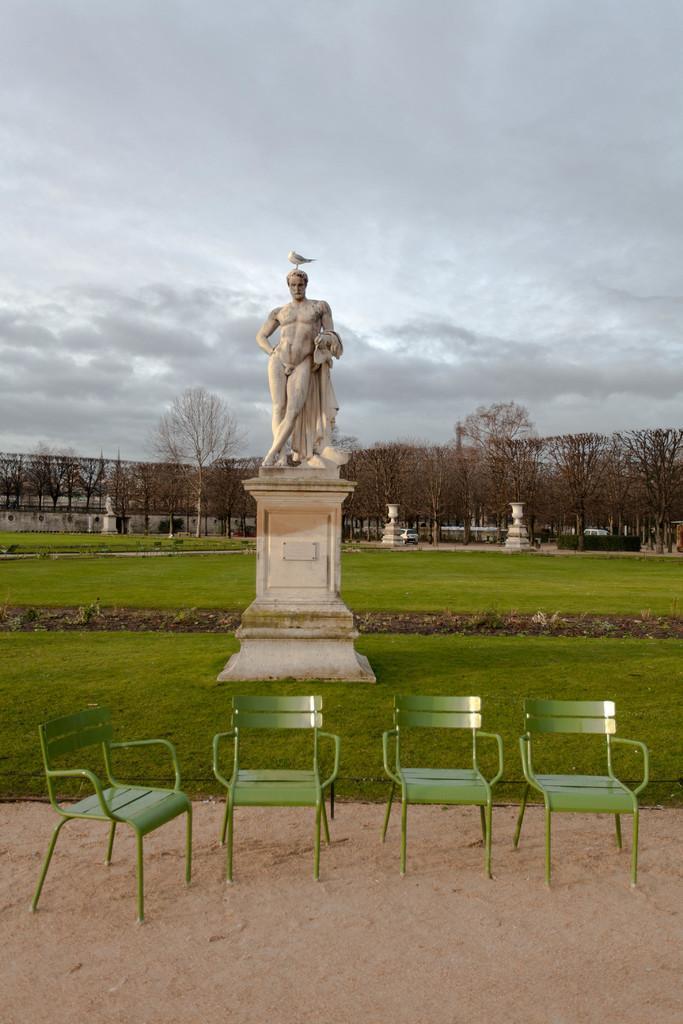Can you describe this image briefly? In the middle of the picture, we see the statue of the man standing. At the bottom of the picture, we see sand and four chairs in green color. Behind that, we see the grass. There are trees and buildings in the background. At the top of the picture, we see the sky. 